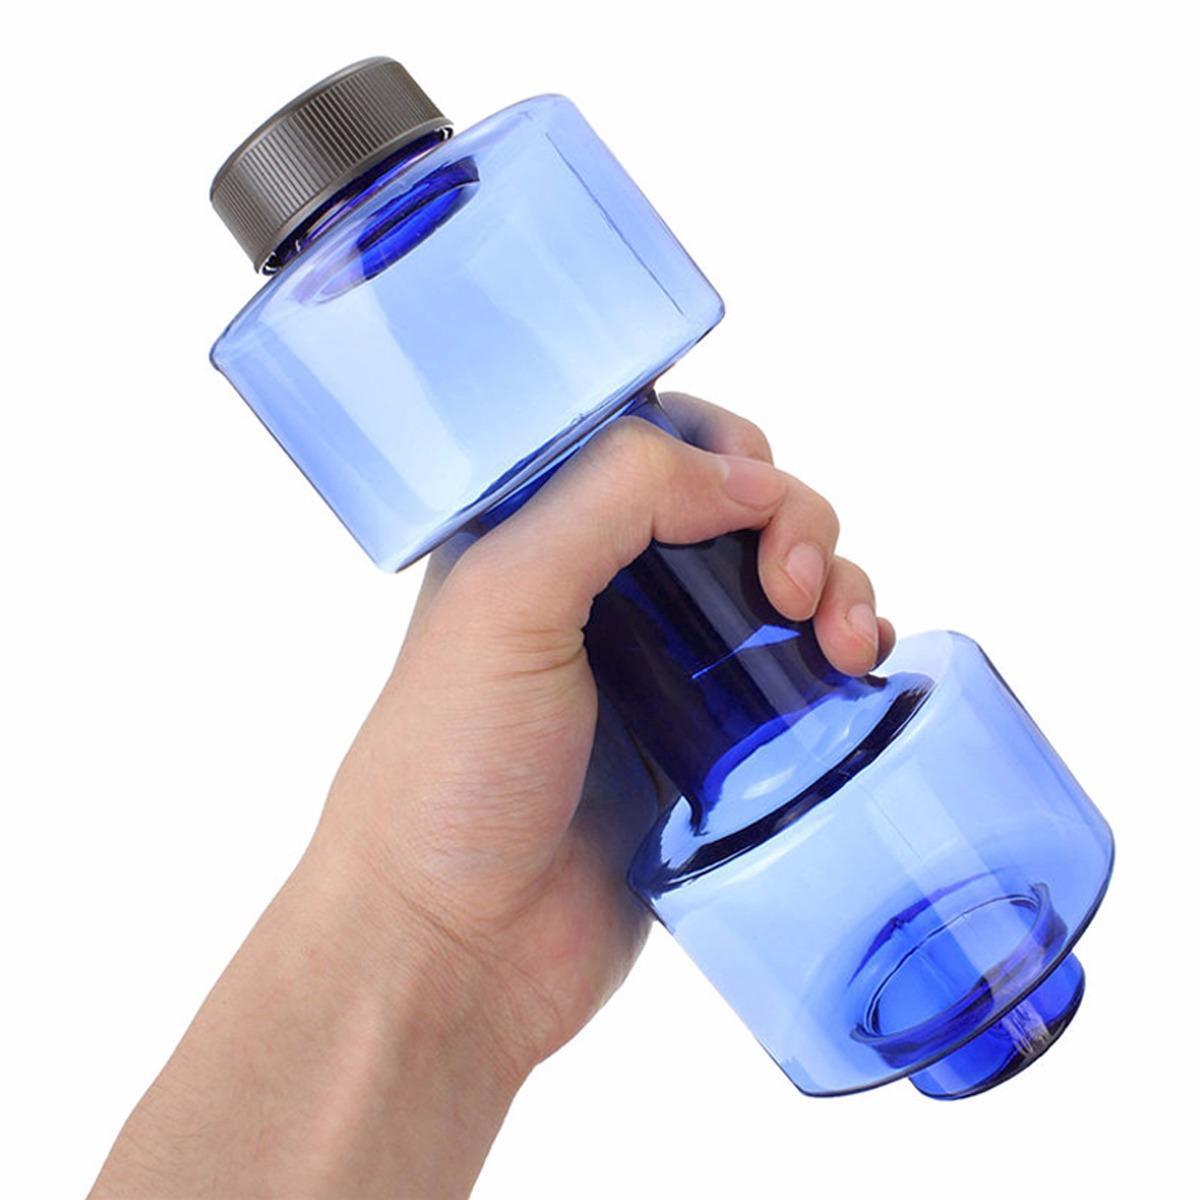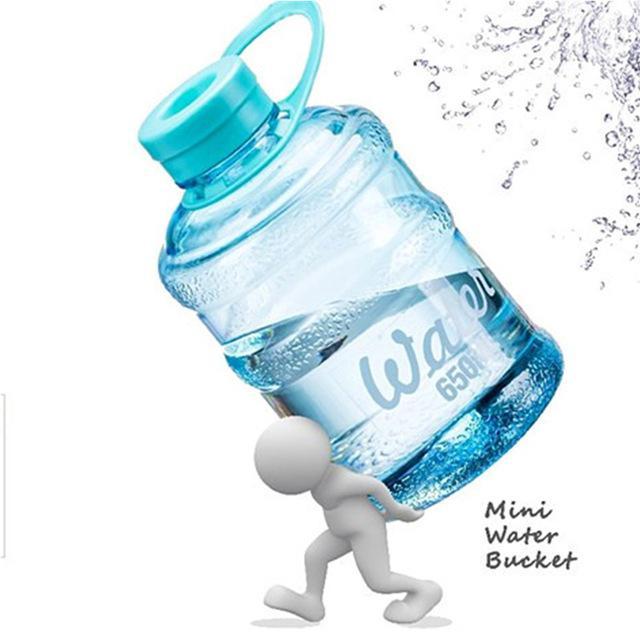The first image is the image on the left, the second image is the image on the right. Examine the images to the left and right. Is the description "In at least one image there is a single water bottle twisted into a penguin water dispenser." accurate? Answer yes or no. No. The first image is the image on the left, the second image is the image on the right. Evaluate the accuracy of this statement regarding the images: "The right image shows an inverted blue water jug, and the left image includes a water jug and a dispenser that looks like a penguin.". Is it true? Answer yes or no. No. 